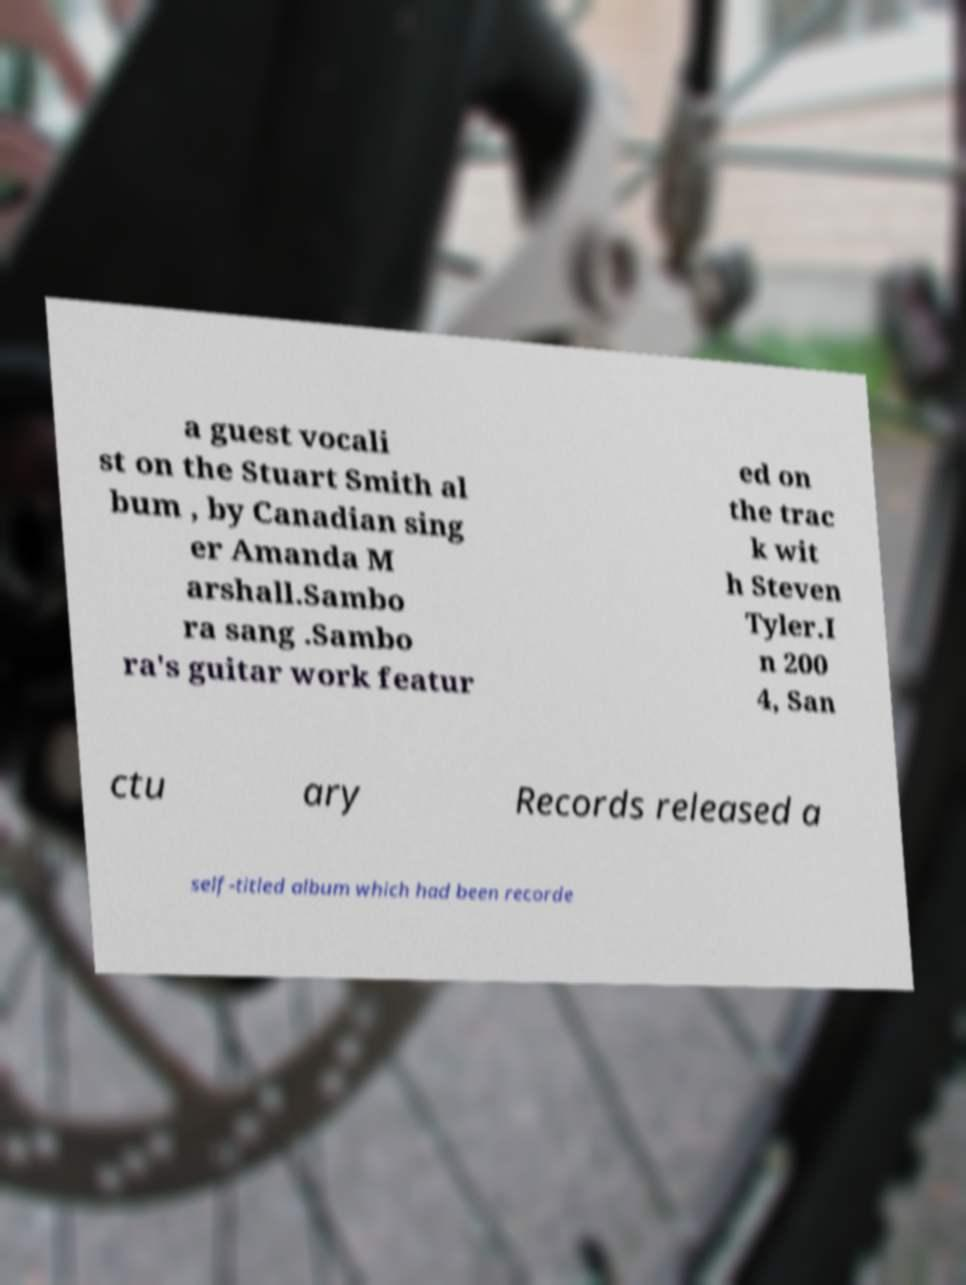Could you assist in decoding the text presented in this image and type it out clearly? a guest vocali st on the Stuart Smith al bum , by Canadian sing er Amanda M arshall.Sambo ra sang .Sambo ra's guitar work featur ed on the trac k wit h Steven Tyler.I n 200 4, San ctu ary Records released a self-titled album which had been recorde 